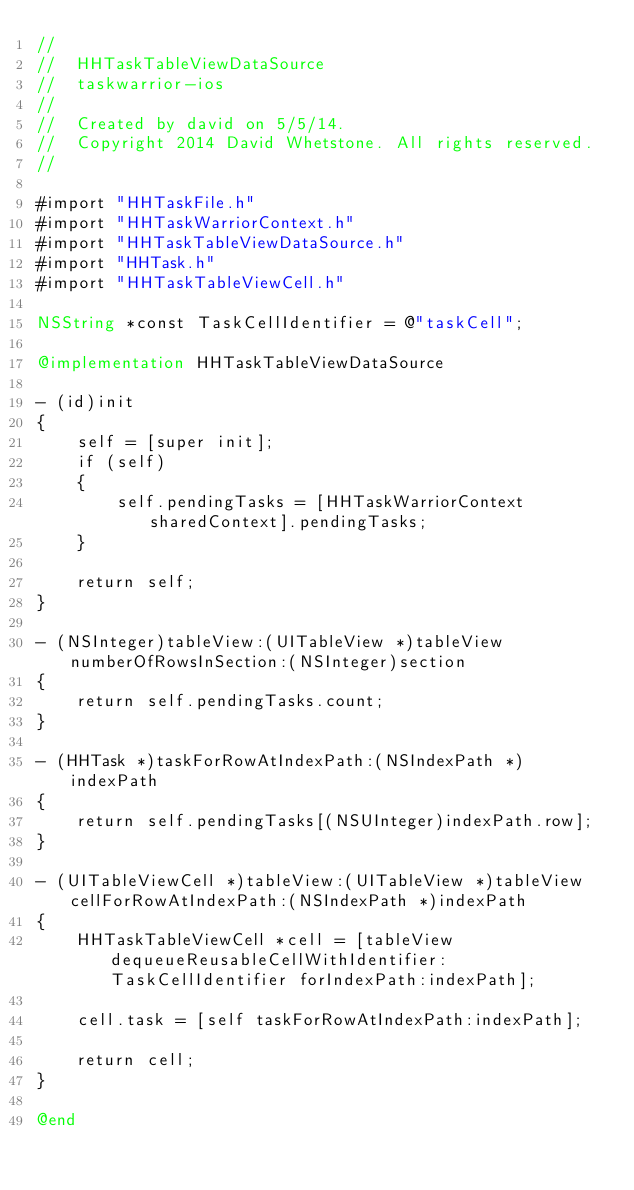<code> <loc_0><loc_0><loc_500><loc_500><_ObjectiveC_>//
//  HHTaskTableViewDataSource
//  taskwarrior-ios
//
//  Created by david on 5/5/14.
//  Copyright 2014 David Whetstone. All rights reserved.
//

#import "HHTaskFile.h"
#import "HHTaskWarriorContext.h"
#import "HHTaskTableViewDataSource.h"
#import "HHTask.h"
#import "HHTaskTableViewCell.h"

NSString *const TaskCellIdentifier = @"taskCell";

@implementation HHTaskTableViewDataSource

- (id)init
{
    self = [super init];
    if (self)
    {
        self.pendingTasks = [HHTaskWarriorContext sharedContext].pendingTasks;
    }

    return self;
}

- (NSInteger)tableView:(UITableView *)tableView numberOfRowsInSection:(NSInteger)section
{
    return self.pendingTasks.count;
}

- (HHTask *)taskForRowAtIndexPath:(NSIndexPath *)indexPath
{
    return self.pendingTasks[(NSUInteger)indexPath.row];
}

- (UITableViewCell *)tableView:(UITableView *)tableView cellForRowAtIndexPath:(NSIndexPath *)indexPath
{
    HHTaskTableViewCell *cell = [tableView dequeueReusableCellWithIdentifier:TaskCellIdentifier forIndexPath:indexPath];

    cell.task = [self taskForRowAtIndexPath:indexPath];

    return cell;
}

@end
</code> 